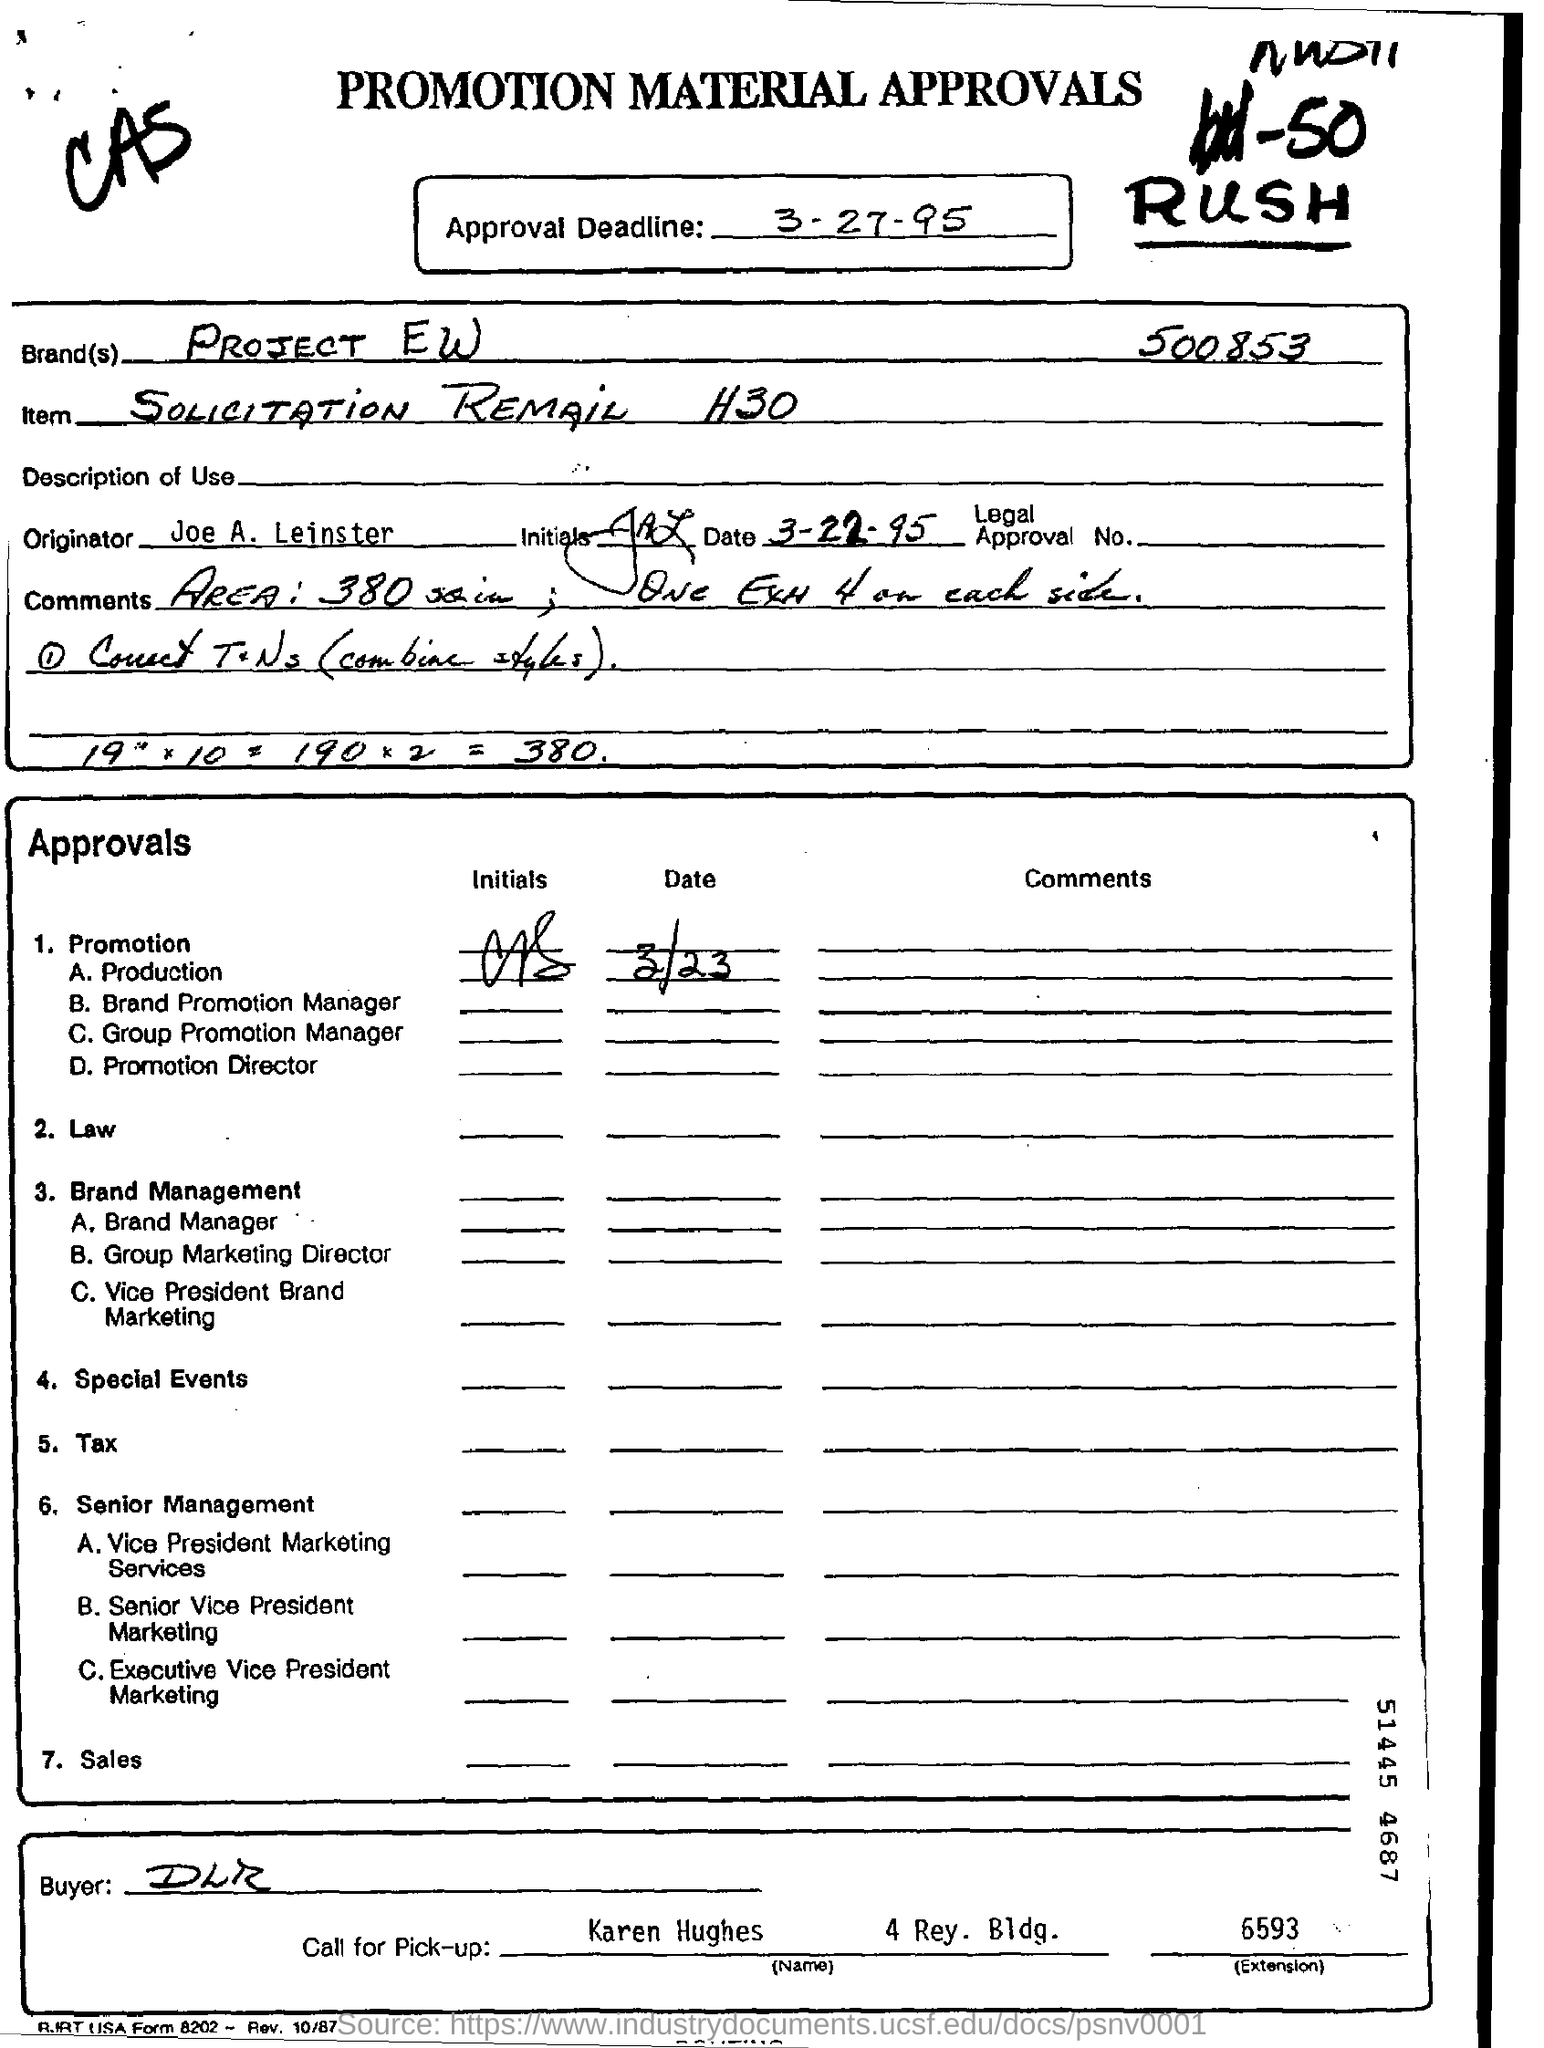When is the approval deadline?
Your answer should be compact. 3- 27- 95. What is the name of the brand?
Provide a succinct answer. PROJECT EW. What is the name of the buyer?
Offer a terse response. DLR. What is the name of the orginator?
Provide a succinct answer. Joe A. Leinster. 